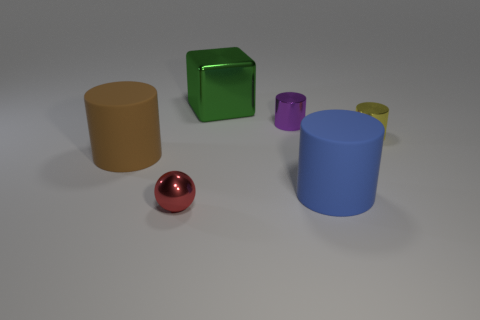What number of other tiny yellow objects have the same material as the small yellow object?
Give a very brief answer. 0. Are there fewer big green metallic things than large blue spheres?
Make the answer very short. No. Do the tiny shiny thing behind the tiny yellow object and the metal block have the same color?
Your response must be concise. No. How many big blue matte objects are to the left of the big cylinder that is to the right of the large cylinder that is on the left side of the metallic block?
Ensure brevity in your answer.  0. There is a red ball; how many small yellow cylinders are left of it?
Make the answer very short. 0. The other big object that is the same shape as the big blue thing is what color?
Your response must be concise. Brown. What is the material of the tiny thing that is left of the blue thing and right of the big green block?
Give a very brief answer. Metal. Does the rubber cylinder that is in front of the brown cylinder have the same size as the ball?
Keep it short and to the point. No. What is the tiny red thing made of?
Provide a succinct answer. Metal. What is the color of the large rubber object that is to the left of the green shiny thing?
Offer a terse response. Brown. 